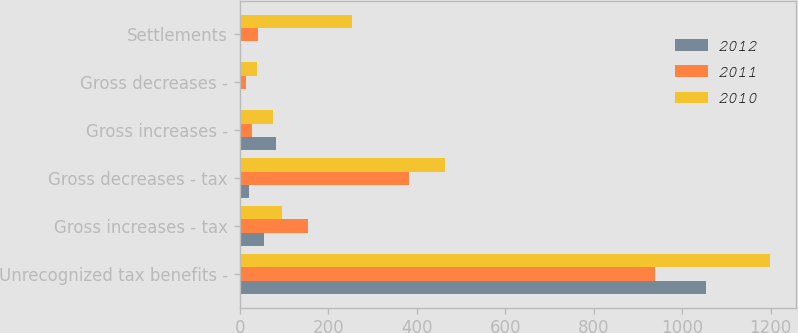Convert chart. <chart><loc_0><loc_0><loc_500><loc_500><stacked_bar_chart><ecel><fcel>Unrecognized tax benefits -<fcel>Gross increases - tax<fcel>Gross decreases - tax<fcel>Gross increases -<fcel>Gross decreases -<fcel>Settlements<nl><fcel>2012<fcel>1055<fcel>55<fcel>20<fcel>83<fcel>1<fcel>1<nl><fcel>2011<fcel>939<fcel>154<fcel>383<fcel>28<fcel>15<fcel>42<nl><fcel>2010<fcel>1198<fcel>95<fcel>465<fcel>76<fcel>40<fcel>254<nl></chart> 